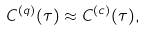<formula> <loc_0><loc_0><loc_500><loc_500>C ^ { ( q ) } ( \tau ) \approx C ^ { ( c ) } ( \tau ) ,</formula> 